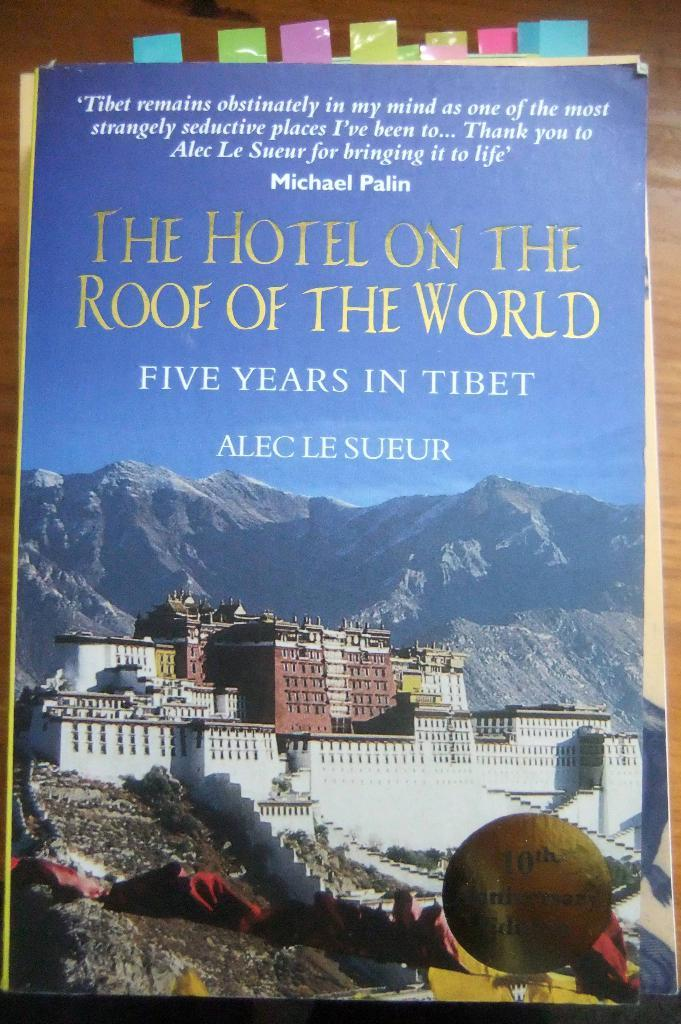<image>
Describe the image concisely. A poster of  the hotel on the roof of the world. 